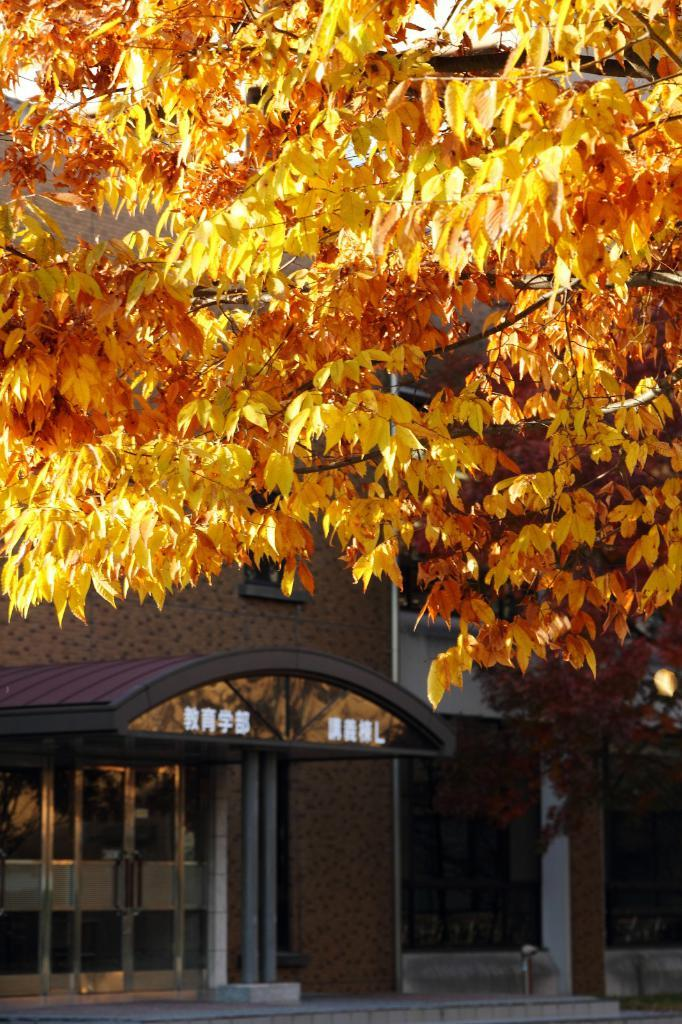What type of plant can be seen in the image? There is a tree in the image. What colors are present on the tree? The tree has yellow and orange colors. What other structure is visible in the image? There is a building in the image. What can be seen in the background of the image? The sky is visible in the background of the image. Where is the bear located in the image? There is no bear present in the image. What type of stove can be seen in the image? There is no stove present in the image. 